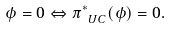<formula> <loc_0><loc_0><loc_500><loc_500>\phi = 0 \Leftrightarrow \pi _ { \ U C } ^ { * } ( \phi ) = 0 .</formula> 